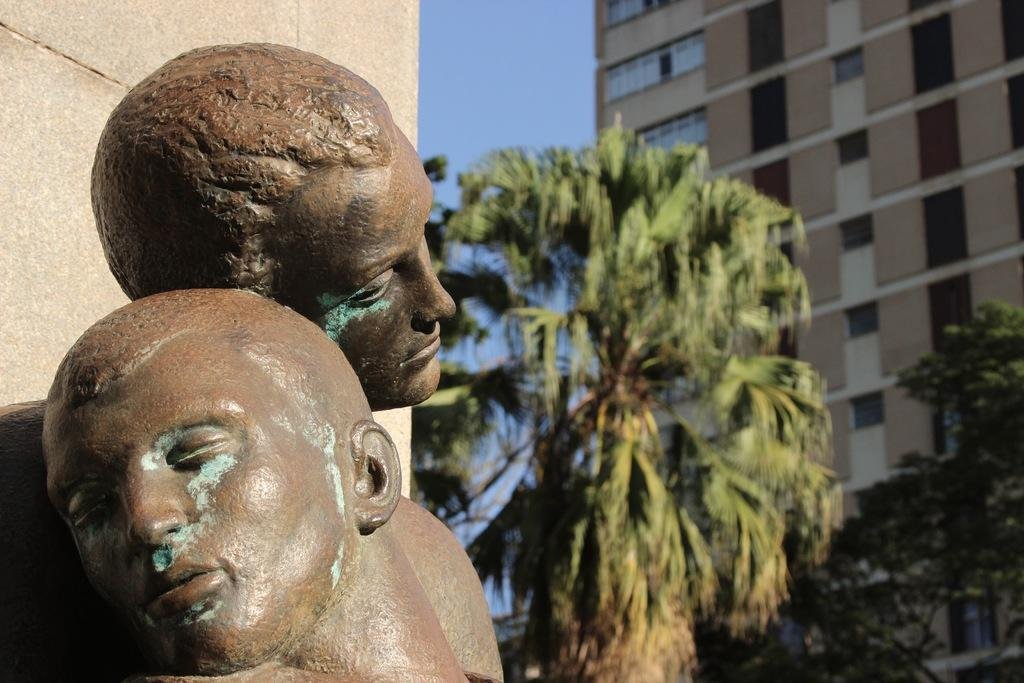What is present in the image that serves as a barrier or divider? There is a wall in the image. What type of artwork can be seen in the image? There are sculptures in the image. What is the color of the sculptures? The sculptures are brown in color. What can be seen in the background of the image? There are trees, a building, and the blue sky in the background of the image. Is there a birthday celebration happening in the image? There is no indication of a birthday celebration in the image. Can you see a camp in the image? There is no camp present in the image. 